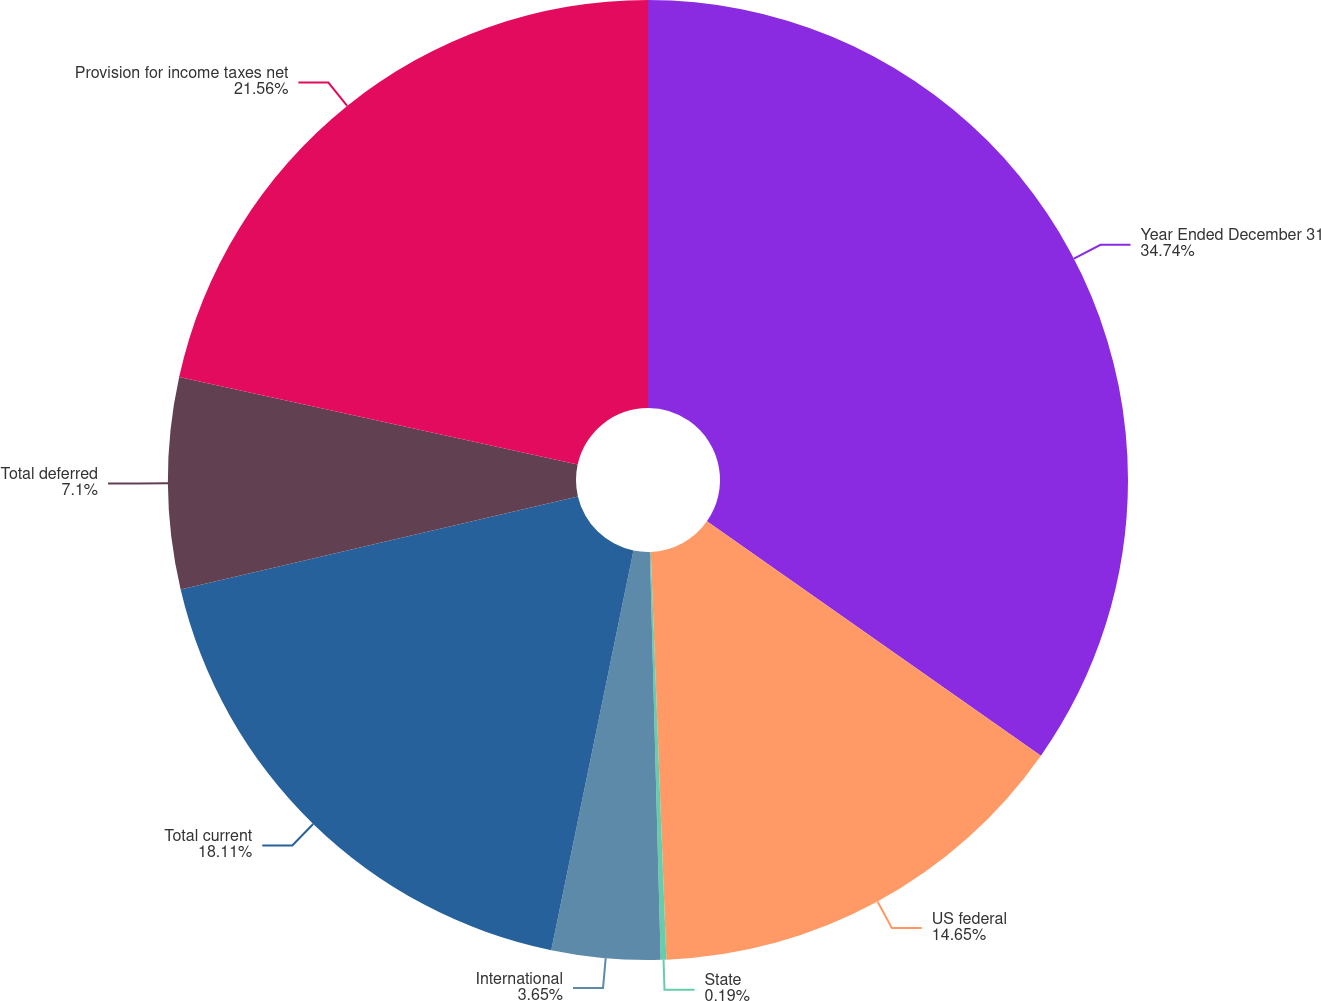Convert chart. <chart><loc_0><loc_0><loc_500><loc_500><pie_chart><fcel>Year Ended December 31<fcel>US federal<fcel>State<fcel>International<fcel>Total current<fcel>Total deferred<fcel>Provision for income taxes net<nl><fcel>34.74%<fcel>14.65%<fcel>0.19%<fcel>3.65%<fcel>18.11%<fcel>7.1%<fcel>21.56%<nl></chart> 